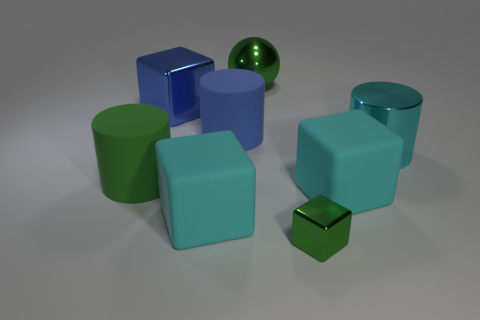Which object seems to be in the foreground and why? The large cyan cylinder appears to be in the foreground due to its size and central placement. It is positioned in front of the other objects, making it a clear focal point of the image. How does the size of objects contribute to the perception of depth in this image? The varied sizes of similar shapes, such as the cylinders and cubes, create a sense of depth. Larger objects appear closer, while smaller ones seem further away. This effect, combined with the positioning and overlapping of the objects, enhances the image's three-dimensional feel. 